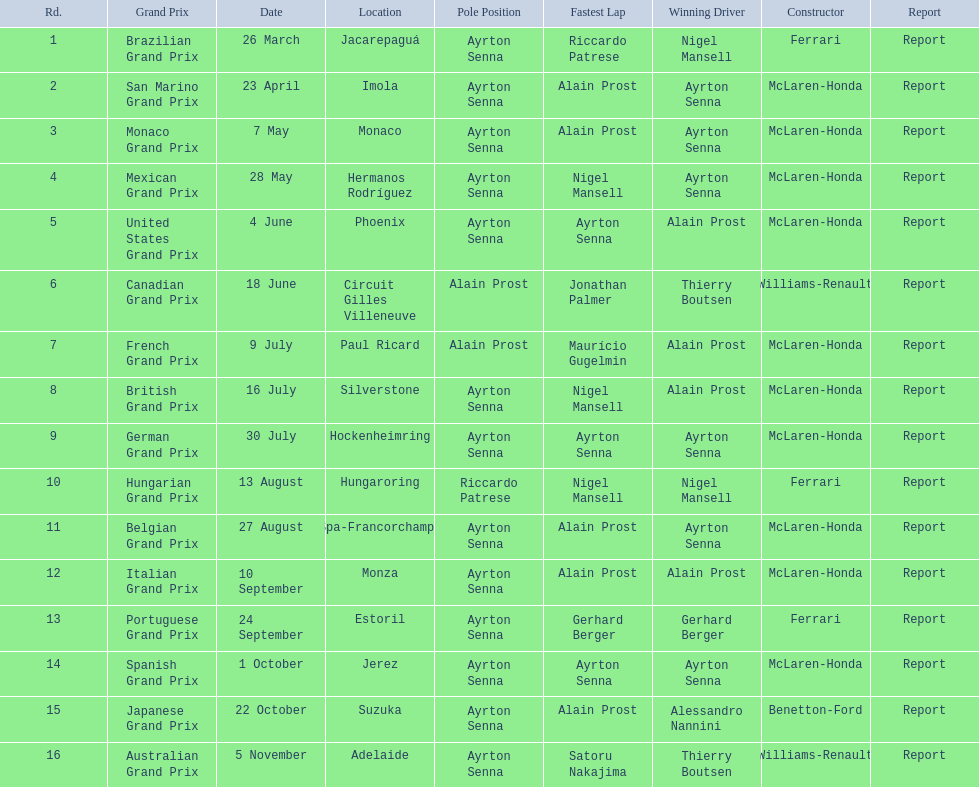In the 1989 formula one season, who were the constructors? Ferrari, McLaren-Honda, McLaren-Honda, McLaren-Honda, McLaren-Honda, Williams-Renault, McLaren-Honda, McLaren-Honda, McLaren-Honda, Ferrari, McLaren-Honda, McLaren-Honda, Ferrari, McLaren-Honda, Benetton-Ford, Williams-Renault. When did benetton ford become the constructor? 22 October. Which race was held on october 22nd? Japanese Grand Prix. 